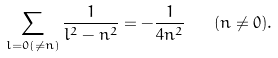<formula> <loc_0><loc_0><loc_500><loc_500>\sum _ { l = 0 ( \neq n ) } \frac { 1 } { l ^ { 2 } - n ^ { 2 } } = - \frac { 1 } { 4 n ^ { 2 } } \quad ( n \neq 0 ) .</formula> 